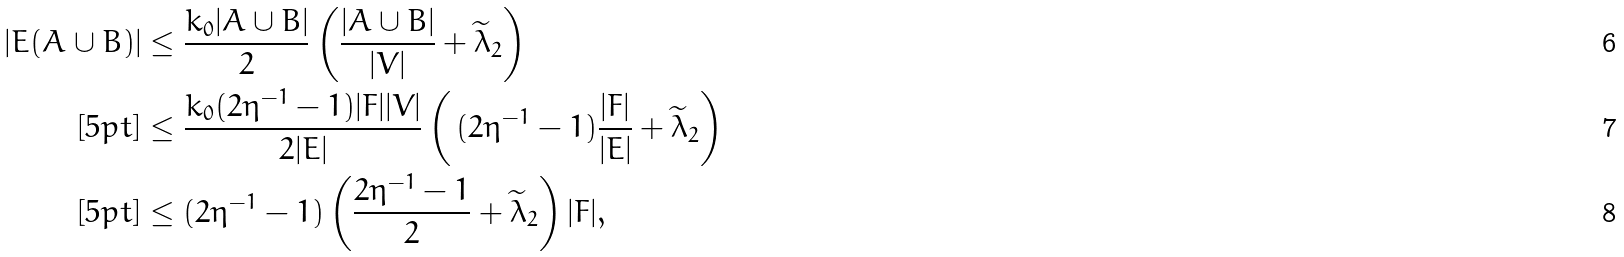<formula> <loc_0><loc_0><loc_500><loc_500>| E ( A \cup B ) | & \leq \frac { k _ { 0 } | A \cup B | } { 2 } \left ( \frac { | A \cup B | } { | V | } + \widetilde { \lambda } _ { 2 } \right ) \\ [ 5 p t ] & \leq \frac { k _ { 0 } ( 2 \eta ^ { - 1 } - 1 ) | F | | V | } { 2 | E | } \left ( \, ( 2 \eta ^ { - 1 } - 1 ) \frac { | F | } { | E | } + \widetilde { \lambda } _ { 2 } \right ) \\ [ 5 p t ] & \leq ( 2 \eta ^ { - 1 } - 1 ) \left ( \frac { 2 \eta ^ { - 1 } - 1 } { 2 } + \widetilde { \lambda } _ { 2 } \right ) | F | ,</formula> 